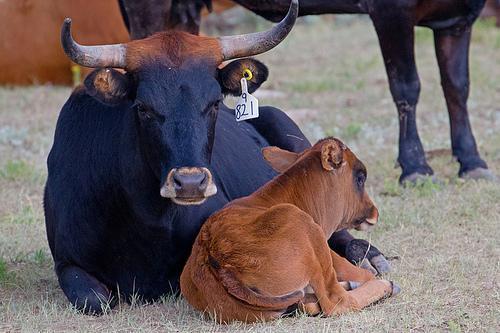How many animals do you see?
Give a very brief answer. 2. 